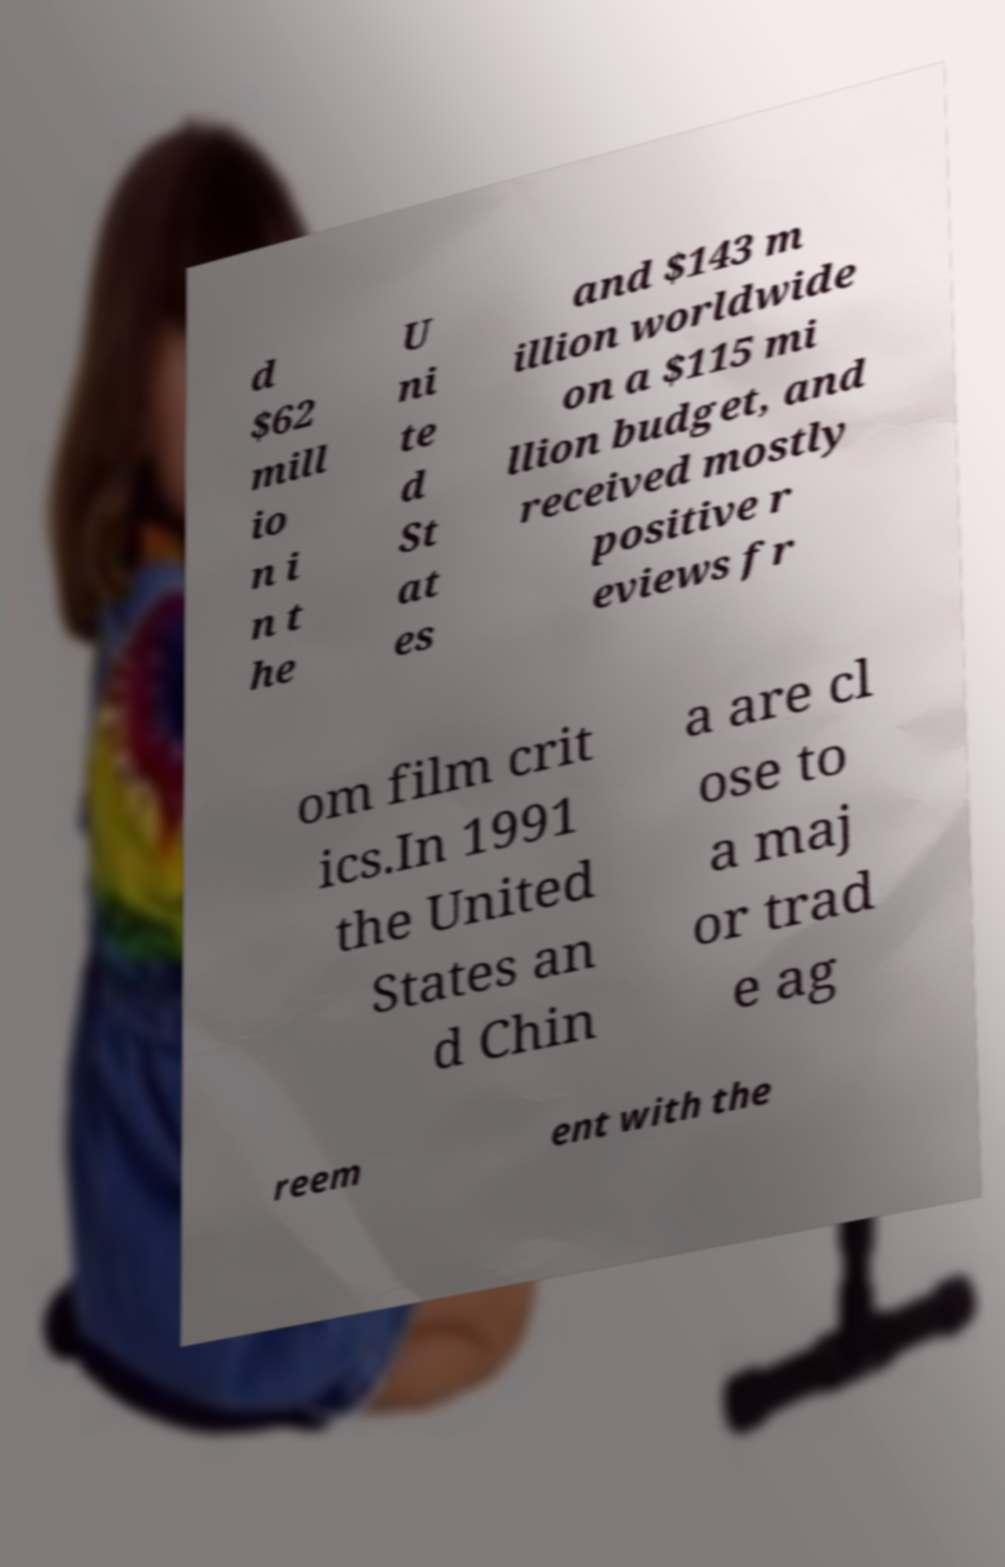Please read and relay the text visible in this image. What does it say? d $62 mill io n i n t he U ni te d St at es and $143 m illion worldwide on a $115 mi llion budget, and received mostly positive r eviews fr om film crit ics.In 1991 the United States an d Chin a are cl ose to a maj or trad e ag reem ent with the 